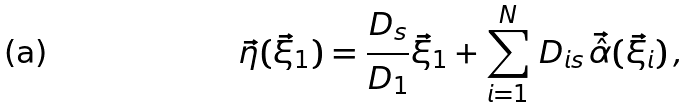Convert formula to latex. <formula><loc_0><loc_0><loc_500><loc_500>\vec { \eta } ( \vec { \xi } _ { 1 } ) = \frac { D _ { s } } { D _ { 1 } } \vec { \xi } _ { 1 } + \sum _ { i = 1 } ^ { N } \, D _ { i s } \, \vec { \hat { \alpha } } ( \vec { \xi } _ { i } ) \, ,</formula> 